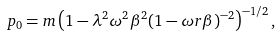Convert formula to latex. <formula><loc_0><loc_0><loc_500><loc_500>p _ { 0 } = m \left ( 1 - \lambda ^ { 2 } \omega ^ { 2 } \beta ^ { 2 } ( 1 - \omega r \beta ) ^ { - 2 } \right ) ^ { - 1 / 2 } ,</formula> 